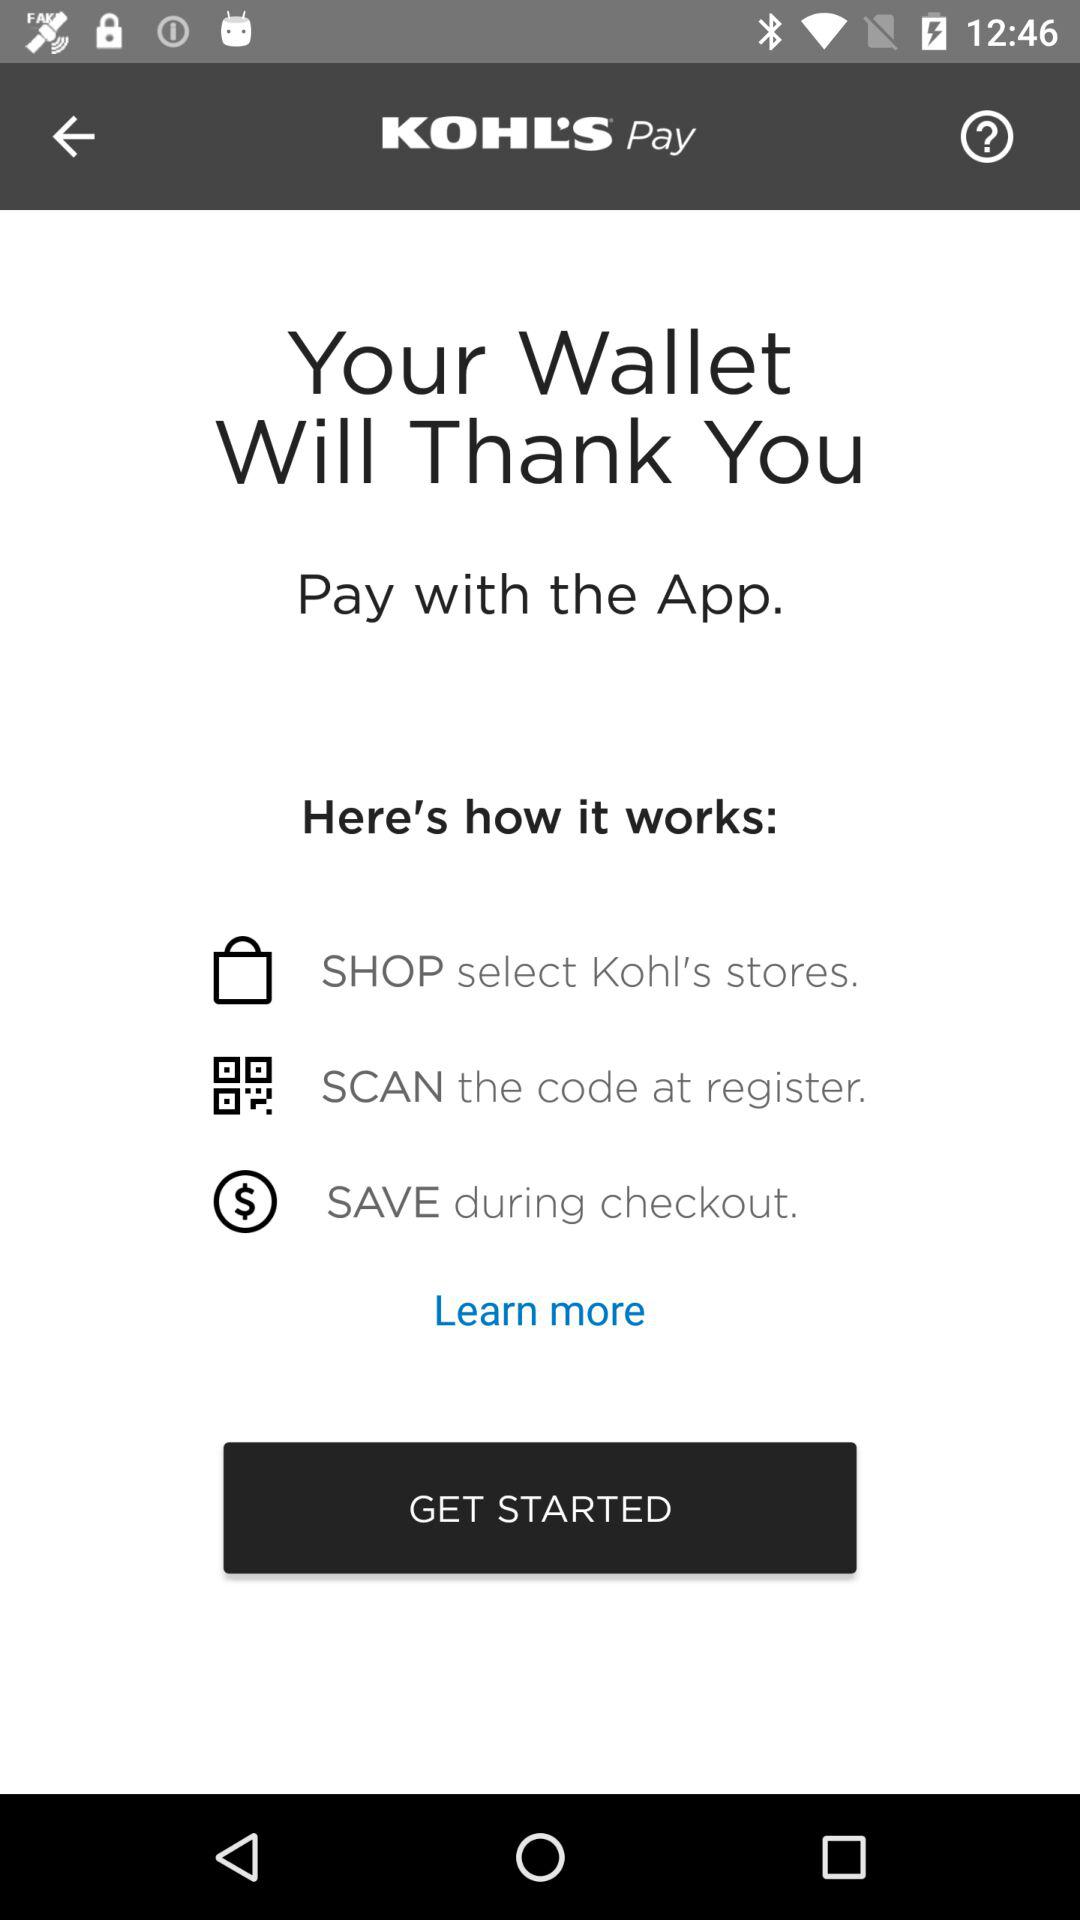What is the name of the application? The name of the application is "KOHL'S Pay". 